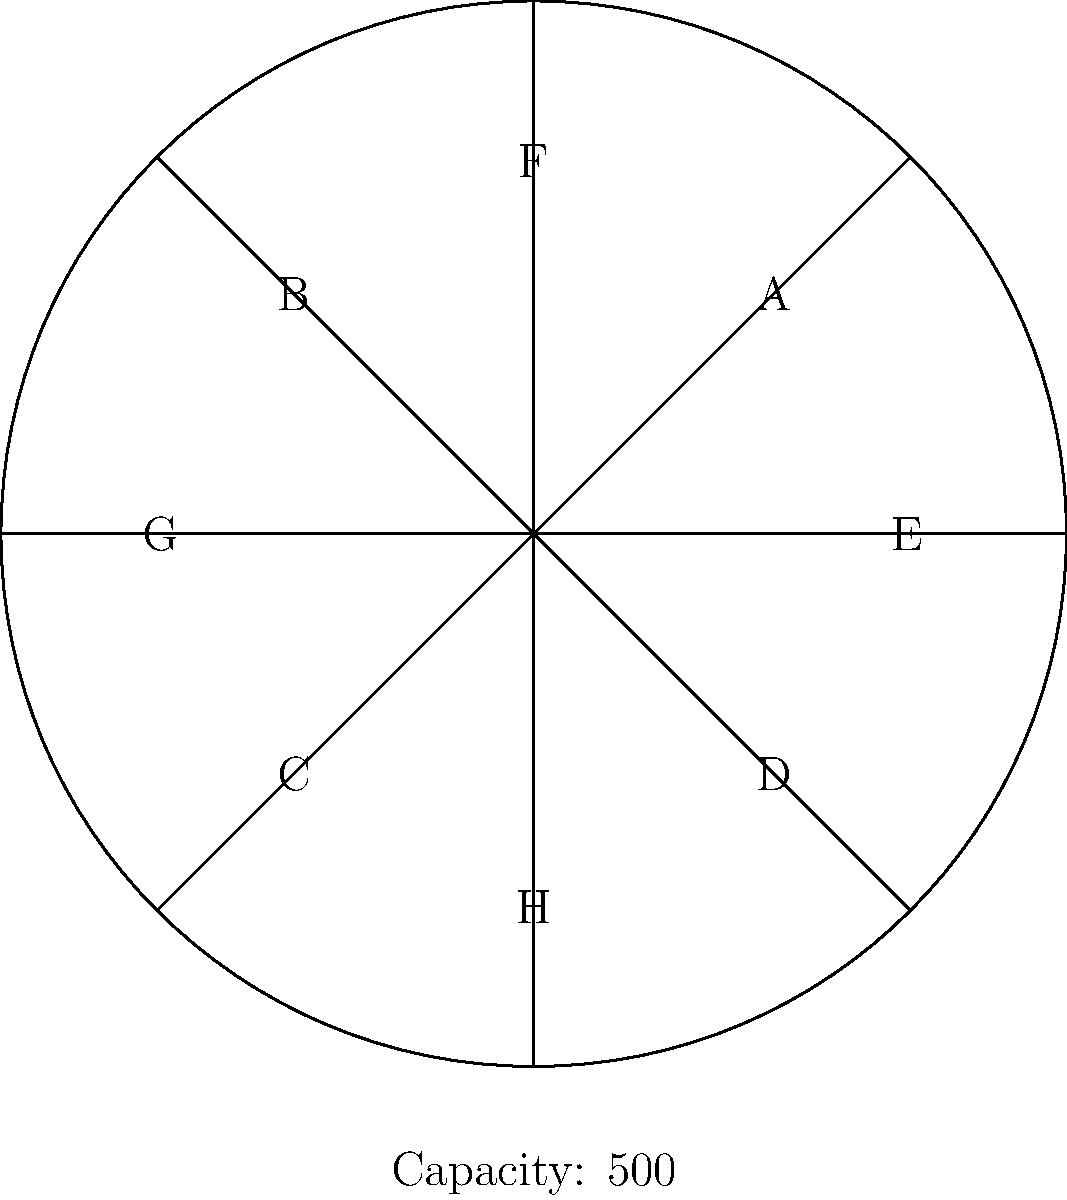As a wrestling manager, you're organizing a luchador event in a circular arena divided into 8 equal sections (A-H). The total capacity is 500 spectators. If sections A, C, E, and G are completely full, and the remaining sections are half-full, estimate the total attendance for the event. Let's approach this step-by-step:

1. First, we need to calculate the capacity of each section:
   Total capacity = 500
   Number of sections = 8
   Capacity per section = $500 \div 8 = 62.5$ spectators

2. Now, let's count the full sections:
   Sections A, C, E, and G are full
   Number of full sections = 4
   Attendance in full sections = $4 \times 62.5 = 250$ spectators

3. Next, let's calculate the half-full sections:
   Sections B, D, F, and H are half-full
   Number of half-full sections = 4
   Capacity of half-full sections = $4 \times (62.5 \div 2) = 125$ spectators

4. Finally, we sum up the attendance:
   Total attendance = Full sections + Half-full sections
   Total attendance = $250 + 125 = 375$ spectators

Therefore, the estimated total attendance for the event is 375 spectators.
Answer: 375 spectators 